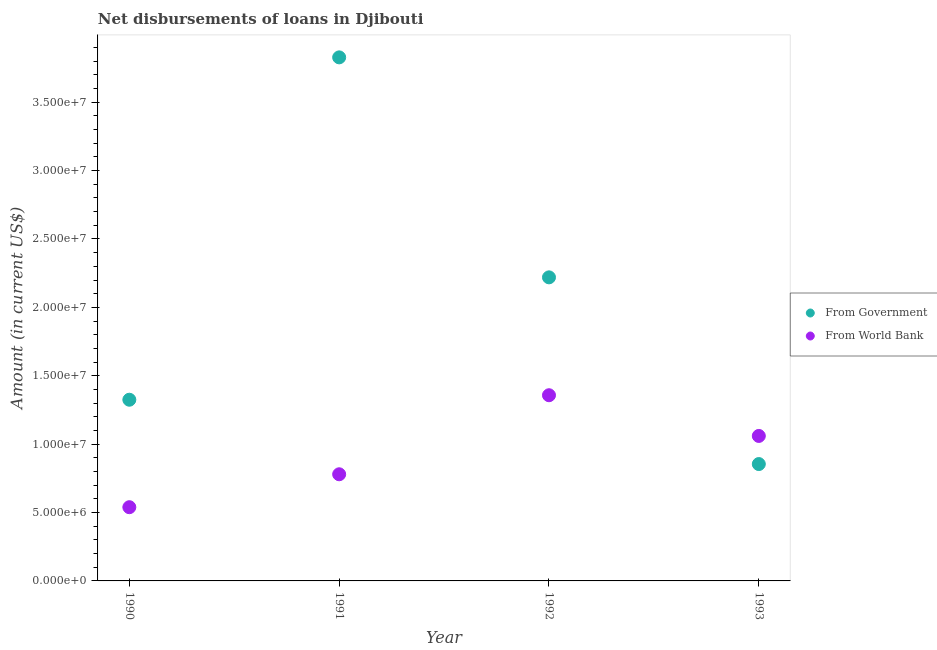How many different coloured dotlines are there?
Offer a terse response. 2. Is the number of dotlines equal to the number of legend labels?
Offer a very short reply. Yes. What is the net disbursements of loan from government in 1993?
Your response must be concise. 8.54e+06. Across all years, what is the maximum net disbursements of loan from government?
Keep it short and to the point. 3.83e+07. Across all years, what is the minimum net disbursements of loan from government?
Provide a short and direct response. 8.54e+06. What is the total net disbursements of loan from government in the graph?
Ensure brevity in your answer.  8.23e+07. What is the difference between the net disbursements of loan from government in 1992 and that in 1993?
Your answer should be compact. 1.37e+07. What is the difference between the net disbursements of loan from government in 1990 and the net disbursements of loan from world bank in 1991?
Make the answer very short. 5.45e+06. What is the average net disbursements of loan from government per year?
Provide a succinct answer. 2.06e+07. In the year 1991, what is the difference between the net disbursements of loan from world bank and net disbursements of loan from government?
Offer a terse response. -3.05e+07. In how many years, is the net disbursements of loan from government greater than 34000000 US$?
Ensure brevity in your answer.  1. What is the ratio of the net disbursements of loan from government in 1990 to that in 1993?
Give a very brief answer. 1.55. Is the net disbursements of loan from world bank in 1991 less than that in 1992?
Give a very brief answer. Yes. Is the difference between the net disbursements of loan from government in 1990 and 1992 greater than the difference between the net disbursements of loan from world bank in 1990 and 1992?
Keep it short and to the point. No. What is the difference between the highest and the second highest net disbursements of loan from government?
Give a very brief answer. 1.61e+07. What is the difference between the highest and the lowest net disbursements of loan from government?
Give a very brief answer. 2.97e+07. Is the net disbursements of loan from government strictly less than the net disbursements of loan from world bank over the years?
Offer a very short reply. No. What is the difference between two consecutive major ticks on the Y-axis?
Give a very brief answer. 5.00e+06. Are the values on the major ticks of Y-axis written in scientific E-notation?
Offer a terse response. Yes. Does the graph contain any zero values?
Make the answer very short. No. Does the graph contain grids?
Provide a succinct answer. No. Where does the legend appear in the graph?
Keep it short and to the point. Center right. What is the title of the graph?
Give a very brief answer. Net disbursements of loans in Djibouti. Does "Borrowers" appear as one of the legend labels in the graph?
Your answer should be very brief. No. What is the label or title of the Y-axis?
Offer a very short reply. Amount (in current US$). What is the Amount (in current US$) of From Government in 1990?
Offer a terse response. 1.32e+07. What is the Amount (in current US$) in From World Bank in 1990?
Ensure brevity in your answer.  5.39e+06. What is the Amount (in current US$) of From Government in 1991?
Offer a terse response. 3.83e+07. What is the Amount (in current US$) in From World Bank in 1991?
Make the answer very short. 7.80e+06. What is the Amount (in current US$) in From Government in 1992?
Your answer should be compact. 2.22e+07. What is the Amount (in current US$) in From World Bank in 1992?
Your answer should be very brief. 1.36e+07. What is the Amount (in current US$) of From Government in 1993?
Offer a very short reply. 8.54e+06. What is the Amount (in current US$) of From World Bank in 1993?
Offer a terse response. 1.06e+07. Across all years, what is the maximum Amount (in current US$) of From Government?
Ensure brevity in your answer.  3.83e+07. Across all years, what is the maximum Amount (in current US$) of From World Bank?
Offer a terse response. 1.36e+07. Across all years, what is the minimum Amount (in current US$) of From Government?
Make the answer very short. 8.54e+06. Across all years, what is the minimum Amount (in current US$) of From World Bank?
Ensure brevity in your answer.  5.39e+06. What is the total Amount (in current US$) of From Government in the graph?
Make the answer very short. 8.23e+07. What is the total Amount (in current US$) of From World Bank in the graph?
Provide a short and direct response. 3.74e+07. What is the difference between the Amount (in current US$) of From Government in 1990 and that in 1991?
Provide a short and direct response. -2.50e+07. What is the difference between the Amount (in current US$) of From World Bank in 1990 and that in 1991?
Give a very brief answer. -2.41e+06. What is the difference between the Amount (in current US$) of From Government in 1990 and that in 1992?
Keep it short and to the point. -8.95e+06. What is the difference between the Amount (in current US$) in From World Bank in 1990 and that in 1992?
Keep it short and to the point. -8.19e+06. What is the difference between the Amount (in current US$) in From Government in 1990 and that in 1993?
Your answer should be very brief. 4.70e+06. What is the difference between the Amount (in current US$) in From World Bank in 1990 and that in 1993?
Your answer should be compact. -5.21e+06. What is the difference between the Amount (in current US$) of From Government in 1991 and that in 1992?
Offer a very short reply. 1.61e+07. What is the difference between the Amount (in current US$) of From World Bank in 1991 and that in 1992?
Your answer should be very brief. -5.78e+06. What is the difference between the Amount (in current US$) in From Government in 1991 and that in 1993?
Make the answer very short. 2.97e+07. What is the difference between the Amount (in current US$) of From World Bank in 1991 and that in 1993?
Your answer should be compact. -2.80e+06. What is the difference between the Amount (in current US$) in From Government in 1992 and that in 1993?
Your response must be concise. 1.37e+07. What is the difference between the Amount (in current US$) of From World Bank in 1992 and that in 1993?
Make the answer very short. 2.98e+06. What is the difference between the Amount (in current US$) in From Government in 1990 and the Amount (in current US$) in From World Bank in 1991?
Offer a very short reply. 5.45e+06. What is the difference between the Amount (in current US$) of From Government in 1990 and the Amount (in current US$) of From World Bank in 1992?
Keep it short and to the point. -3.28e+05. What is the difference between the Amount (in current US$) of From Government in 1990 and the Amount (in current US$) of From World Bank in 1993?
Provide a short and direct response. 2.65e+06. What is the difference between the Amount (in current US$) in From Government in 1991 and the Amount (in current US$) in From World Bank in 1992?
Give a very brief answer. 2.47e+07. What is the difference between the Amount (in current US$) of From Government in 1991 and the Amount (in current US$) of From World Bank in 1993?
Provide a succinct answer. 2.77e+07. What is the difference between the Amount (in current US$) in From Government in 1992 and the Amount (in current US$) in From World Bank in 1993?
Your answer should be very brief. 1.16e+07. What is the average Amount (in current US$) in From Government per year?
Offer a very short reply. 2.06e+07. What is the average Amount (in current US$) of From World Bank per year?
Ensure brevity in your answer.  9.34e+06. In the year 1990, what is the difference between the Amount (in current US$) of From Government and Amount (in current US$) of From World Bank?
Your answer should be very brief. 7.86e+06. In the year 1991, what is the difference between the Amount (in current US$) in From Government and Amount (in current US$) in From World Bank?
Your answer should be very brief. 3.05e+07. In the year 1992, what is the difference between the Amount (in current US$) of From Government and Amount (in current US$) of From World Bank?
Your answer should be compact. 8.62e+06. In the year 1993, what is the difference between the Amount (in current US$) of From Government and Amount (in current US$) of From World Bank?
Make the answer very short. -2.06e+06. What is the ratio of the Amount (in current US$) of From Government in 1990 to that in 1991?
Offer a very short reply. 0.35. What is the ratio of the Amount (in current US$) in From World Bank in 1990 to that in 1991?
Ensure brevity in your answer.  0.69. What is the ratio of the Amount (in current US$) in From Government in 1990 to that in 1992?
Your answer should be compact. 0.6. What is the ratio of the Amount (in current US$) in From World Bank in 1990 to that in 1992?
Provide a short and direct response. 0.4. What is the ratio of the Amount (in current US$) in From Government in 1990 to that in 1993?
Offer a terse response. 1.55. What is the ratio of the Amount (in current US$) of From World Bank in 1990 to that in 1993?
Offer a very short reply. 0.51. What is the ratio of the Amount (in current US$) in From Government in 1991 to that in 1992?
Your answer should be compact. 1.72. What is the ratio of the Amount (in current US$) in From World Bank in 1991 to that in 1992?
Provide a succinct answer. 0.57. What is the ratio of the Amount (in current US$) of From Government in 1991 to that in 1993?
Keep it short and to the point. 4.48. What is the ratio of the Amount (in current US$) in From World Bank in 1991 to that in 1993?
Provide a short and direct response. 0.74. What is the ratio of the Amount (in current US$) in From Government in 1992 to that in 1993?
Provide a short and direct response. 2.6. What is the ratio of the Amount (in current US$) in From World Bank in 1992 to that in 1993?
Provide a short and direct response. 1.28. What is the difference between the highest and the second highest Amount (in current US$) of From Government?
Provide a succinct answer. 1.61e+07. What is the difference between the highest and the second highest Amount (in current US$) in From World Bank?
Your response must be concise. 2.98e+06. What is the difference between the highest and the lowest Amount (in current US$) of From Government?
Keep it short and to the point. 2.97e+07. What is the difference between the highest and the lowest Amount (in current US$) in From World Bank?
Your answer should be very brief. 8.19e+06. 